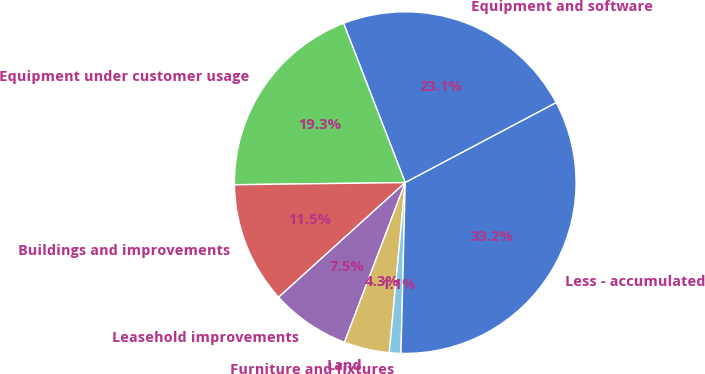<chart> <loc_0><loc_0><loc_500><loc_500><pie_chart><fcel>Equipment and software<fcel>Equipment under customer usage<fcel>Buildings and improvements<fcel>Leasehold improvements<fcel>Land<fcel>Furniture and fixtures<fcel>Less - accumulated<nl><fcel>23.13%<fcel>19.32%<fcel>11.51%<fcel>7.5%<fcel>4.3%<fcel>1.09%<fcel>33.15%<nl></chart> 